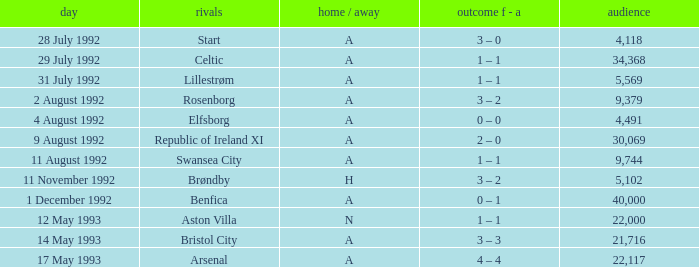What was the H/A on 29 july 1992? A. 